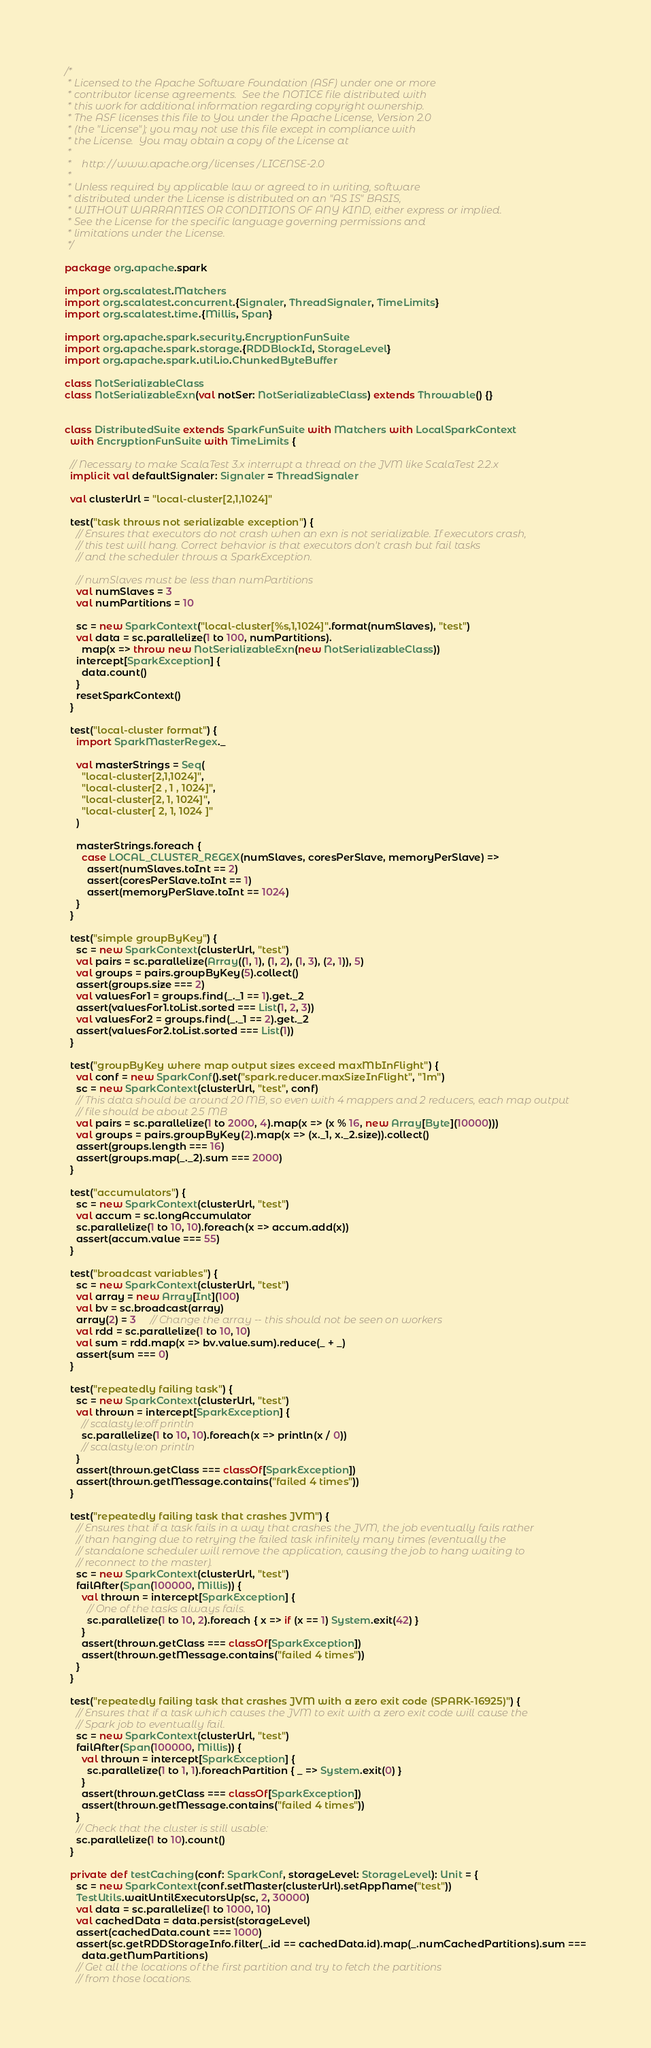Convert code to text. <code><loc_0><loc_0><loc_500><loc_500><_Scala_>/*
 * Licensed to the Apache Software Foundation (ASF) under one or more
 * contributor license agreements.  See the NOTICE file distributed with
 * this work for additional information regarding copyright ownership.
 * The ASF licenses this file to You under the Apache License, Version 2.0
 * (the "License"); you may not use this file except in compliance with
 * the License.  You may obtain a copy of the License at
 *
 *    http://www.apache.org/licenses/LICENSE-2.0
 *
 * Unless required by applicable law or agreed to in writing, software
 * distributed under the License is distributed on an "AS IS" BASIS,
 * WITHOUT WARRANTIES OR CONDITIONS OF ANY KIND, either express or implied.
 * See the License for the specific language governing permissions and
 * limitations under the License.
 */

package org.apache.spark

import org.scalatest.Matchers
import org.scalatest.concurrent.{Signaler, ThreadSignaler, TimeLimits}
import org.scalatest.time.{Millis, Span}

import org.apache.spark.security.EncryptionFunSuite
import org.apache.spark.storage.{RDDBlockId, StorageLevel}
import org.apache.spark.util.io.ChunkedByteBuffer

class NotSerializableClass
class NotSerializableExn(val notSer: NotSerializableClass) extends Throwable() {}


class DistributedSuite extends SparkFunSuite with Matchers with LocalSparkContext
  with EncryptionFunSuite with TimeLimits {

  // Necessary to make ScalaTest 3.x interrupt a thread on the JVM like ScalaTest 2.2.x
  implicit val defaultSignaler: Signaler = ThreadSignaler

  val clusterUrl = "local-cluster[2,1,1024]"

  test("task throws not serializable exception") {
    // Ensures that executors do not crash when an exn is not serializable. If executors crash,
    // this test will hang. Correct behavior is that executors don't crash but fail tasks
    // and the scheduler throws a SparkException.

    // numSlaves must be less than numPartitions
    val numSlaves = 3
    val numPartitions = 10

    sc = new SparkContext("local-cluster[%s,1,1024]".format(numSlaves), "test")
    val data = sc.parallelize(1 to 100, numPartitions).
      map(x => throw new NotSerializableExn(new NotSerializableClass))
    intercept[SparkException] {
      data.count()
    }
    resetSparkContext()
  }

  test("local-cluster format") {
    import SparkMasterRegex._

    val masterStrings = Seq(
      "local-cluster[2,1,1024]",
      "local-cluster[2 , 1 , 1024]",
      "local-cluster[2, 1, 1024]",
      "local-cluster[ 2, 1, 1024 ]"
    )

    masterStrings.foreach {
      case LOCAL_CLUSTER_REGEX(numSlaves, coresPerSlave, memoryPerSlave) =>
        assert(numSlaves.toInt == 2)
        assert(coresPerSlave.toInt == 1)
        assert(memoryPerSlave.toInt == 1024)
    }
  }

  test("simple groupByKey") {
    sc = new SparkContext(clusterUrl, "test")
    val pairs = sc.parallelize(Array((1, 1), (1, 2), (1, 3), (2, 1)), 5)
    val groups = pairs.groupByKey(5).collect()
    assert(groups.size === 2)
    val valuesFor1 = groups.find(_._1 == 1).get._2
    assert(valuesFor1.toList.sorted === List(1, 2, 3))
    val valuesFor2 = groups.find(_._1 == 2).get._2
    assert(valuesFor2.toList.sorted === List(1))
  }

  test("groupByKey where map output sizes exceed maxMbInFlight") {
    val conf = new SparkConf().set("spark.reducer.maxSizeInFlight", "1m")
    sc = new SparkContext(clusterUrl, "test", conf)
    // This data should be around 20 MB, so even with 4 mappers and 2 reducers, each map output
    // file should be about 2.5 MB
    val pairs = sc.parallelize(1 to 2000, 4).map(x => (x % 16, new Array[Byte](10000)))
    val groups = pairs.groupByKey(2).map(x => (x._1, x._2.size)).collect()
    assert(groups.length === 16)
    assert(groups.map(_._2).sum === 2000)
  }

  test("accumulators") {
    sc = new SparkContext(clusterUrl, "test")
    val accum = sc.longAccumulator
    sc.parallelize(1 to 10, 10).foreach(x => accum.add(x))
    assert(accum.value === 55)
  }

  test("broadcast variables") {
    sc = new SparkContext(clusterUrl, "test")
    val array = new Array[Int](100)
    val bv = sc.broadcast(array)
    array(2) = 3     // Change the array -- this should not be seen on workers
    val rdd = sc.parallelize(1 to 10, 10)
    val sum = rdd.map(x => bv.value.sum).reduce(_ + _)
    assert(sum === 0)
  }

  test("repeatedly failing task") {
    sc = new SparkContext(clusterUrl, "test")
    val thrown = intercept[SparkException] {
      // scalastyle:off println
      sc.parallelize(1 to 10, 10).foreach(x => println(x / 0))
      // scalastyle:on println
    }
    assert(thrown.getClass === classOf[SparkException])
    assert(thrown.getMessage.contains("failed 4 times"))
  }

  test("repeatedly failing task that crashes JVM") {
    // Ensures that if a task fails in a way that crashes the JVM, the job eventually fails rather
    // than hanging due to retrying the failed task infinitely many times (eventually the
    // standalone scheduler will remove the application, causing the job to hang waiting to
    // reconnect to the master).
    sc = new SparkContext(clusterUrl, "test")
    failAfter(Span(100000, Millis)) {
      val thrown = intercept[SparkException] {
        // One of the tasks always fails.
        sc.parallelize(1 to 10, 2).foreach { x => if (x == 1) System.exit(42) }
      }
      assert(thrown.getClass === classOf[SparkException])
      assert(thrown.getMessage.contains("failed 4 times"))
    }
  }

  test("repeatedly failing task that crashes JVM with a zero exit code (SPARK-16925)") {
    // Ensures that if a task which causes the JVM to exit with a zero exit code will cause the
    // Spark job to eventually fail.
    sc = new SparkContext(clusterUrl, "test")
    failAfter(Span(100000, Millis)) {
      val thrown = intercept[SparkException] {
        sc.parallelize(1 to 1, 1).foreachPartition { _ => System.exit(0) }
      }
      assert(thrown.getClass === classOf[SparkException])
      assert(thrown.getMessage.contains("failed 4 times"))
    }
    // Check that the cluster is still usable:
    sc.parallelize(1 to 10).count()
  }

  private def testCaching(conf: SparkConf, storageLevel: StorageLevel): Unit = {
    sc = new SparkContext(conf.setMaster(clusterUrl).setAppName("test"))
    TestUtils.waitUntilExecutorsUp(sc, 2, 30000)
    val data = sc.parallelize(1 to 1000, 10)
    val cachedData = data.persist(storageLevel)
    assert(cachedData.count === 1000)
    assert(sc.getRDDStorageInfo.filter(_.id == cachedData.id).map(_.numCachedPartitions).sum ===
      data.getNumPartitions)
    // Get all the locations of the first partition and try to fetch the partitions
    // from those locations.</code> 